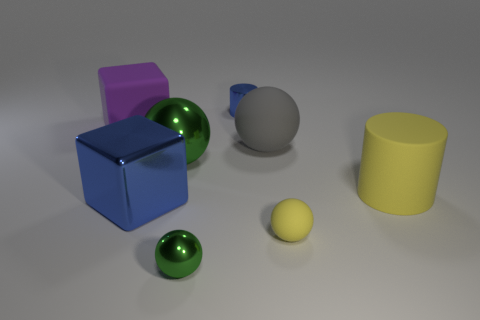Subtract 1 balls. How many balls are left? 3 Add 1 red shiny balls. How many objects exist? 9 Subtract all blocks. How many objects are left? 6 Subtract 0 cyan balls. How many objects are left? 8 Subtract all gray rubber balls. Subtract all rubber spheres. How many objects are left? 5 Add 7 purple things. How many purple things are left? 8 Add 5 large green spheres. How many large green spheres exist? 6 